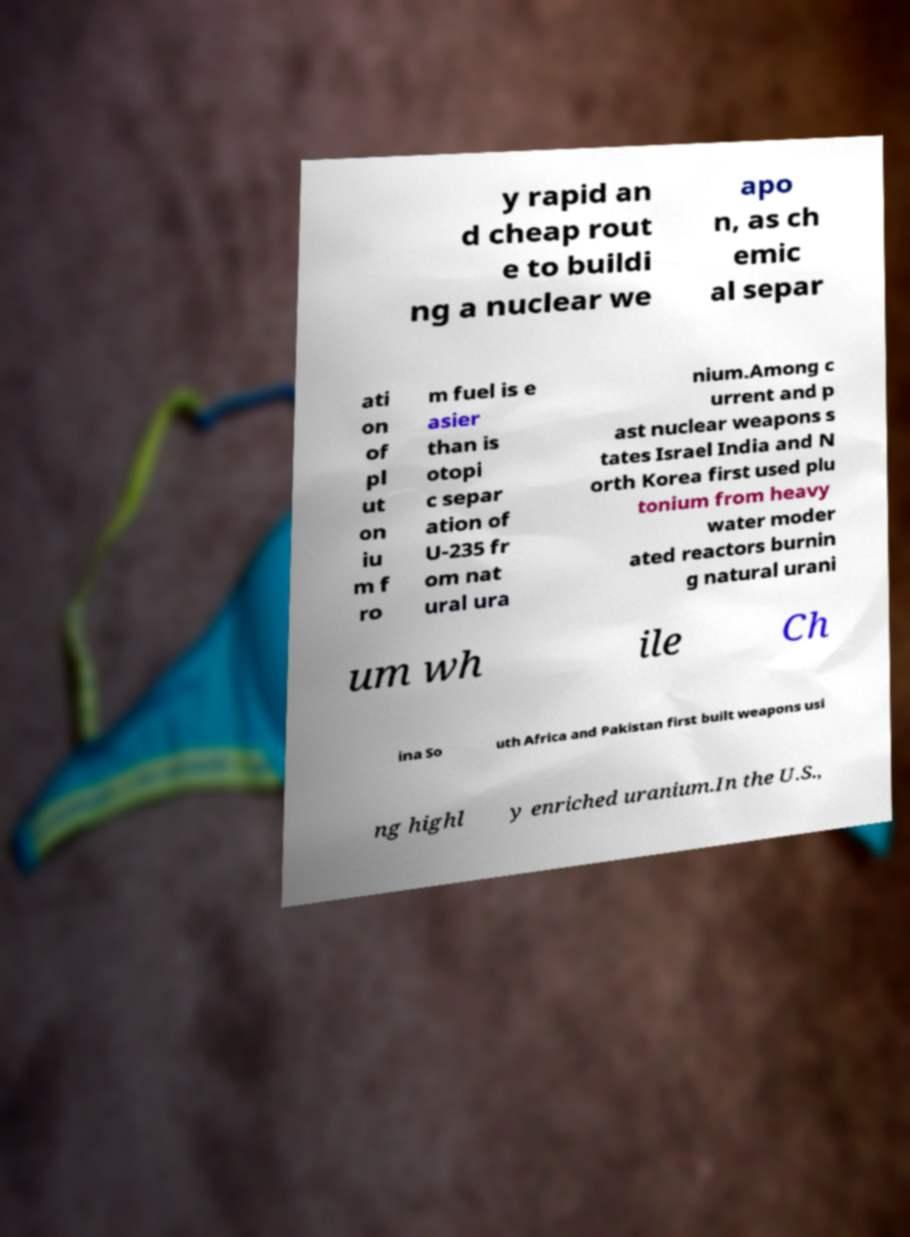Can you read and provide the text displayed in the image?This photo seems to have some interesting text. Can you extract and type it out for me? y rapid an d cheap rout e to buildi ng a nuclear we apo n, as ch emic al separ ati on of pl ut on iu m f ro m fuel is e asier than is otopi c separ ation of U-235 fr om nat ural ura nium.Among c urrent and p ast nuclear weapons s tates Israel India and N orth Korea first used plu tonium from heavy water moder ated reactors burnin g natural urani um wh ile Ch ina So uth Africa and Pakistan first built weapons usi ng highl y enriched uranium.In the U.S., 